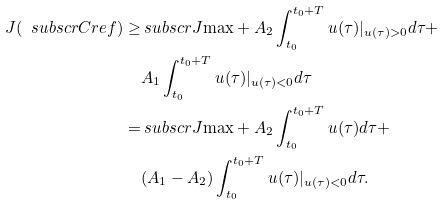<formula> <loc_0><loc_0><loc_500><loc_500>J ( \ s u b s c r { C } { r e f } ) \geq & \ s u b s c r { J } { \max } + A _ { 2 } \int _ { t _ { 0 } } ^ { t _ { 0 } + T } u ( \tau ) | _ { u ( \tau ) > 0 } d \tau + \\ & A _ { 1 } \int _ { t _ { 0 } } ^ { t _ { 0 } + T } u ( \tau ) | _ { u ( \tau ) < 0 } d \tau \\ = & \ s u b s c r { J } { \max } + A _ { 2 } \int _ { t _ { 0 } } ^ { t _ { 0 } + T } u ( \tau ) d \tau + \\ & ( A _ { 1 } - A _ { 2 } ) \int _ { t _ { 0 } } ^ { t _ { 0 } + T } u ( \tau ) | _ { u ( \tau ) < 0 } d \tau .</formula> 